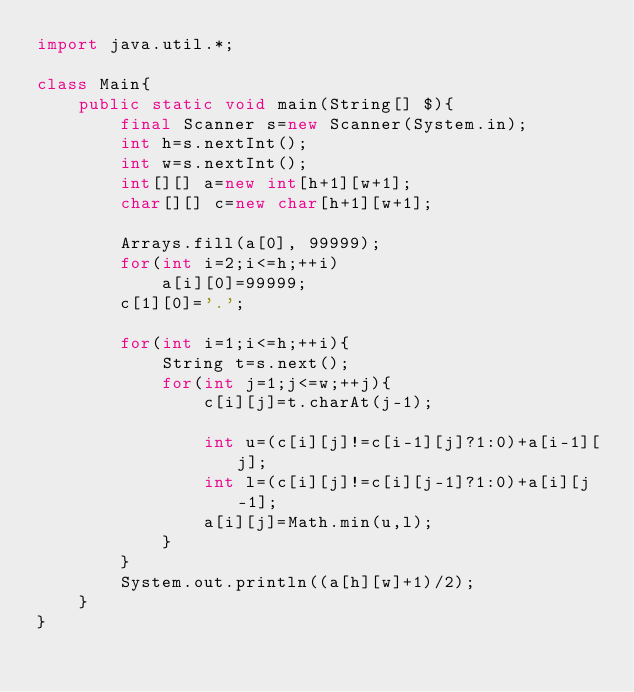Convert code to text. <code><loc_0><loc_0><loc_500><loc_500><_Java_>import java.util.*;

class Main{
	public static void main(String[] $){
		final Scanner s=new Scanner(System.in);
		int h=s.nextInt();
		int w=s.nextInt();
		int[][] a=new int[h+1][w+1];
		char[][] c=new char[h+1][w+1];

		Arrays.fill(a[0], 99999);
		for(int i=2;i<=h;++i)
			a[i][0]=99999;
		c[1][0]='.';

		for(int i=1;i<=h;++i){
			String t=s.next();
			for(int j=1;j<=w;++j){
				c[i][j]=t.charAt(j-1);

				int u=(c[i][j]!=c[i-1][j]?1:0)+a[i-1][j];
				int l=(c[i][j]!=c[i][j-1]?1:0)+a[i][j-1];
				a[i][j]=Math.min(u,l);
			}
		}
		System.out.println((a[h][w]+1)/2);
	}
}
</code> 